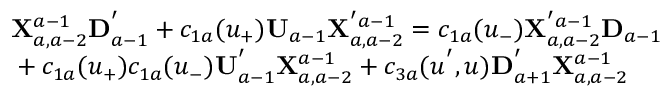Convert formula to latex. <formula><loc_0><loc_0><loc_500><loc_500>\begin{array} { l } { { { X } _ { a , a - 2 } ^ { a - 1 } { D } _ { a - 1 } ^ { ^ { \prime } } + c _ { 1 a } ( u _ { + } ) { U } _ { a - 1 } { X } _ { a , a - 2 } ^ { ^ { \prime } a - 1 } = c _ { 1 a } ( u _ { - } ) { X } _ { a , a - 2 } ^ { ^ { \prime } a - 1 } { D } _ { a - 1 } } } \\ { { + c _ { 1 a } ( u _ { + } ) c _ { 1 a } ( u _ { - } ) { U } _ { a - 1 } ^ { ^ { \prime } } { X } _ { a , a - 2 } ^ { a - 1 } + c _ { 3 a } ( u ^ { ^ { \prime } } , u ) { D } _ { a + 1 } ^ { ^ { \prime } } { X } _ { a , a - 2 } ^ { a - 1 } } } \end{array}</formula> 